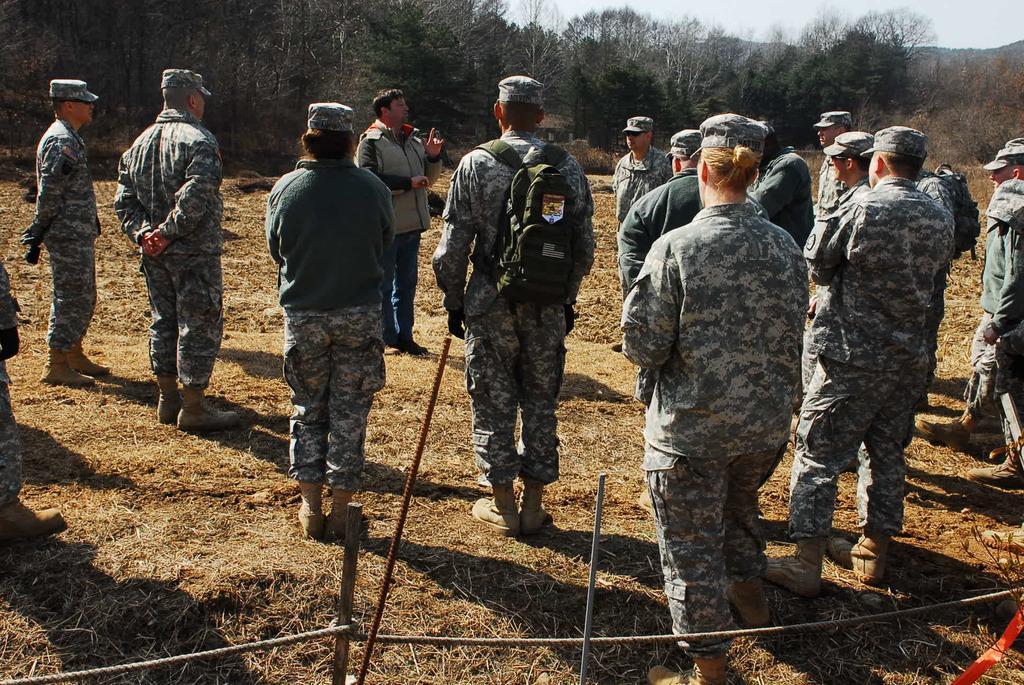Describe this image in one or two sentences. In this image there are group of officers standing on the ground. In the background there are trees. In the middle there is a person who is standing on the ground is giving the instructions. At the bottom there are poles to which there are wires. 